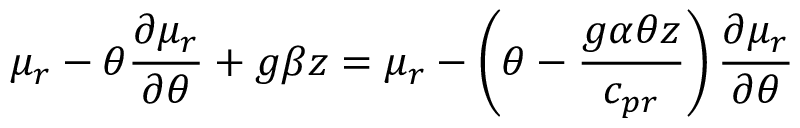Convert formula to latex. <formula><loc_0><loc_0><loc_500><loc_500>\mu _ { r } - \theta \frac { \partial \mu _ { r } } { \partial \theta } + g \beta z = \mu _ { r } - \left ( \theta - \frac { g \alpha \theta z } { c _ { p r } } \right ) \frac { \partial \mu _ { r } } { \partial \theta }</formula> 